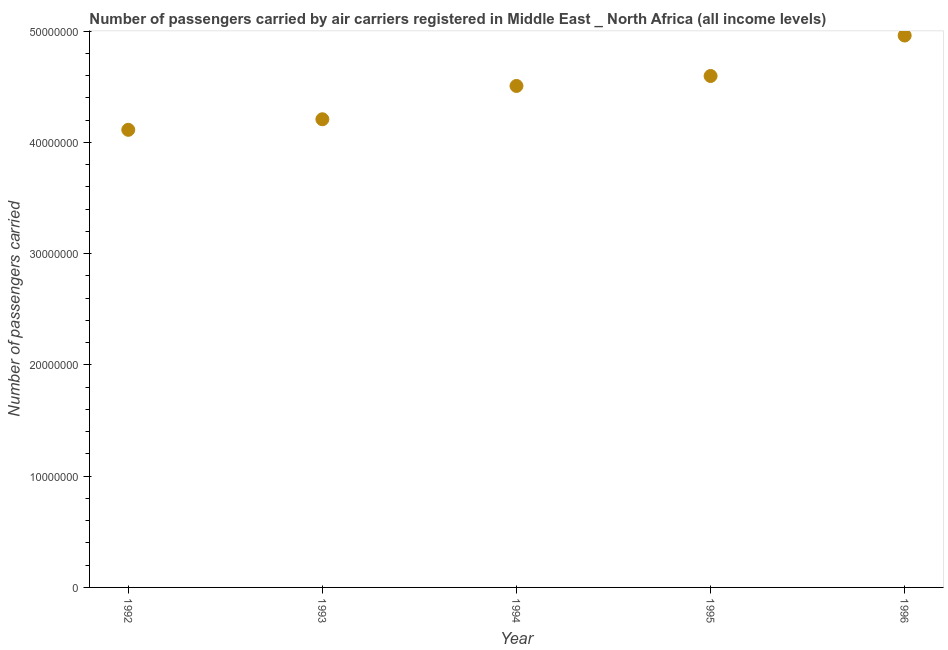What is the number of passengers carried in 1996?
Make the answer very short. 4.96e+07. Across all years, what is the maximum number of passengers carried?
Provide a succinct answer. 4.96e+07. Across all years, what is the minimum number of passengers carried?
Your answer should be compact. 4.11e+07. What is the sum of the number of passengers carried?
Provide a succinct answer. 2.24e+08. What is the difference between the number of passengers carried in 1993 and 1995?
Make the answer very short. -3.89e+06. What is the average number of passengers carried per year?
Offer a terse response. 4.48e+07. What is the median number of passengers carried?
Offer a terse response. 4.51e+07. Do a majority of the years between 1996 and 1993 (inclusive) have number of passengers carried greater than 4000000 ?
Offer a terse response. Yes. What is the ratio of the number of passengers carried in 1992 to that in 1994?
Provide a succinct answer. 0.91. Is the number of passengers carried in 1993 less than that in 1996?
Offer a very short reply. Yes. Is the difference between the number of passengers carried in 1993 and 1994 greater than the difference between any two years?
Make the answer very short. No. What is the difference between the highest and the second highest number of passengers carried?
Provide a succinct answer. 3.64e+06. Is the sum of the number of passengers carried in 1992 and 1993 greater than the maximum number of passengers carried across all years?
Make the answer very short. Yes. What is the difference between the highest and the lowest number of passengers carried?
Give a very brief answer. 8.48e+06. In how many years, is the number of passengers carried greater than the average number of passengers carried taken over all years?
Your answer should be compact. 3. Does the number of passengers carried monotonically increase over the years?
Offer a very short reply. Yes. What is the difference between two consecutive major ticks on the Y-axis?
Your answer should be very brief. 1.00e+07. Are the values on the major ticks of Y-axis written in scientific E-notation?
Offer a terse response. No. Does the graph contain grids?
Your answer should be compact. No. What is the title of the graph?
Your response must be concise. Number of passengers carried by air carriers registered in Middle East _ North Africa (all income levels). What is the label or title of the Y-axis?
Your response must be concise. Number of passengers carried. What is the Number of passengers carried in 1992?
Keep it short and to the point. 4.11e+07. What is the Number of passengers carried in 1993?
Provide a succinct answer. 4.21e+07. What is the Number of passengers carried in 1994?
Provide a succinct answer. 4.51e+07. What is the Number of passengers carried in 1995?
Your answer should be very brief. 4.60e+07. What is the Number of passengers carried in 1996?
Your response must be concise. 4.96e+07. What is the difference between the Number of passengers carried in 1992 and 1993?
Offer a very short reply. -9.49e+05. What is the difference between the Number of passengers carried in 1992 and 1994?
Provide a short and direct response. -3.94e+06. What is the difference between the Number of passengers carried in 1992 and 1995?
Give a very brief answer. -4.84e+06. What is the difference between the Number of passengers carried in 1992 and 1996?
Offer a very short reply. -8.48e+06. What is the difference between the Number of passengers carried in 1993 and 1994?
Make the answer very short. -2.99e+06. What is the difference between the Number of passengers carried in 1993 and 1995?
Provide a succinct answer. -3.89e+06. What is the difference between the Number of passengers carried in 1993 and 1996?
Offer a terse response. -7.53e+06. What is the difference between the Number of passengers carried in 1994 and 1995?
Your response must be concise. -8.95e+05. What is the difference between the Number of passengers carried in 1994 and 1996?
Provide a succinct answer. -4.53e+06. What is the difference between the Number of passengers carried in 1995 and 1996?
Offer a terse response. -3.64e+06. What is the ratio of the Number of passengers carried in 1992 to that in 1995?
Your answer should be very brief. 0.9. What is the ratio of the Number of passengers carried in 1992 to that in 1996?
Offer a terse response. 0.83. What is the ratio of the Number of passengers carried in 1993 to that in 1994?
Offer a terse response. 0.93. What is the ratio of the Number of passengers carried in 1993 to that in 1995?
Your answer should be very brief. 0.92. What is the ratio of the Number of passengers carried in 1993 to that in 1996?
Provide a succinct answer. 0.85. What is the ratio of the Number of passengers carried in 1994 to that in 1995?
Make the answer very short. 0.98. What is the ratio of the Number of passengers carried in 1994 to that in 1996?
Your answer should be very brief. 0.91. What is the ratio of the Number of passengers carried in 1995 to that in 1996?
Keep it short and to the point. 0.93. 